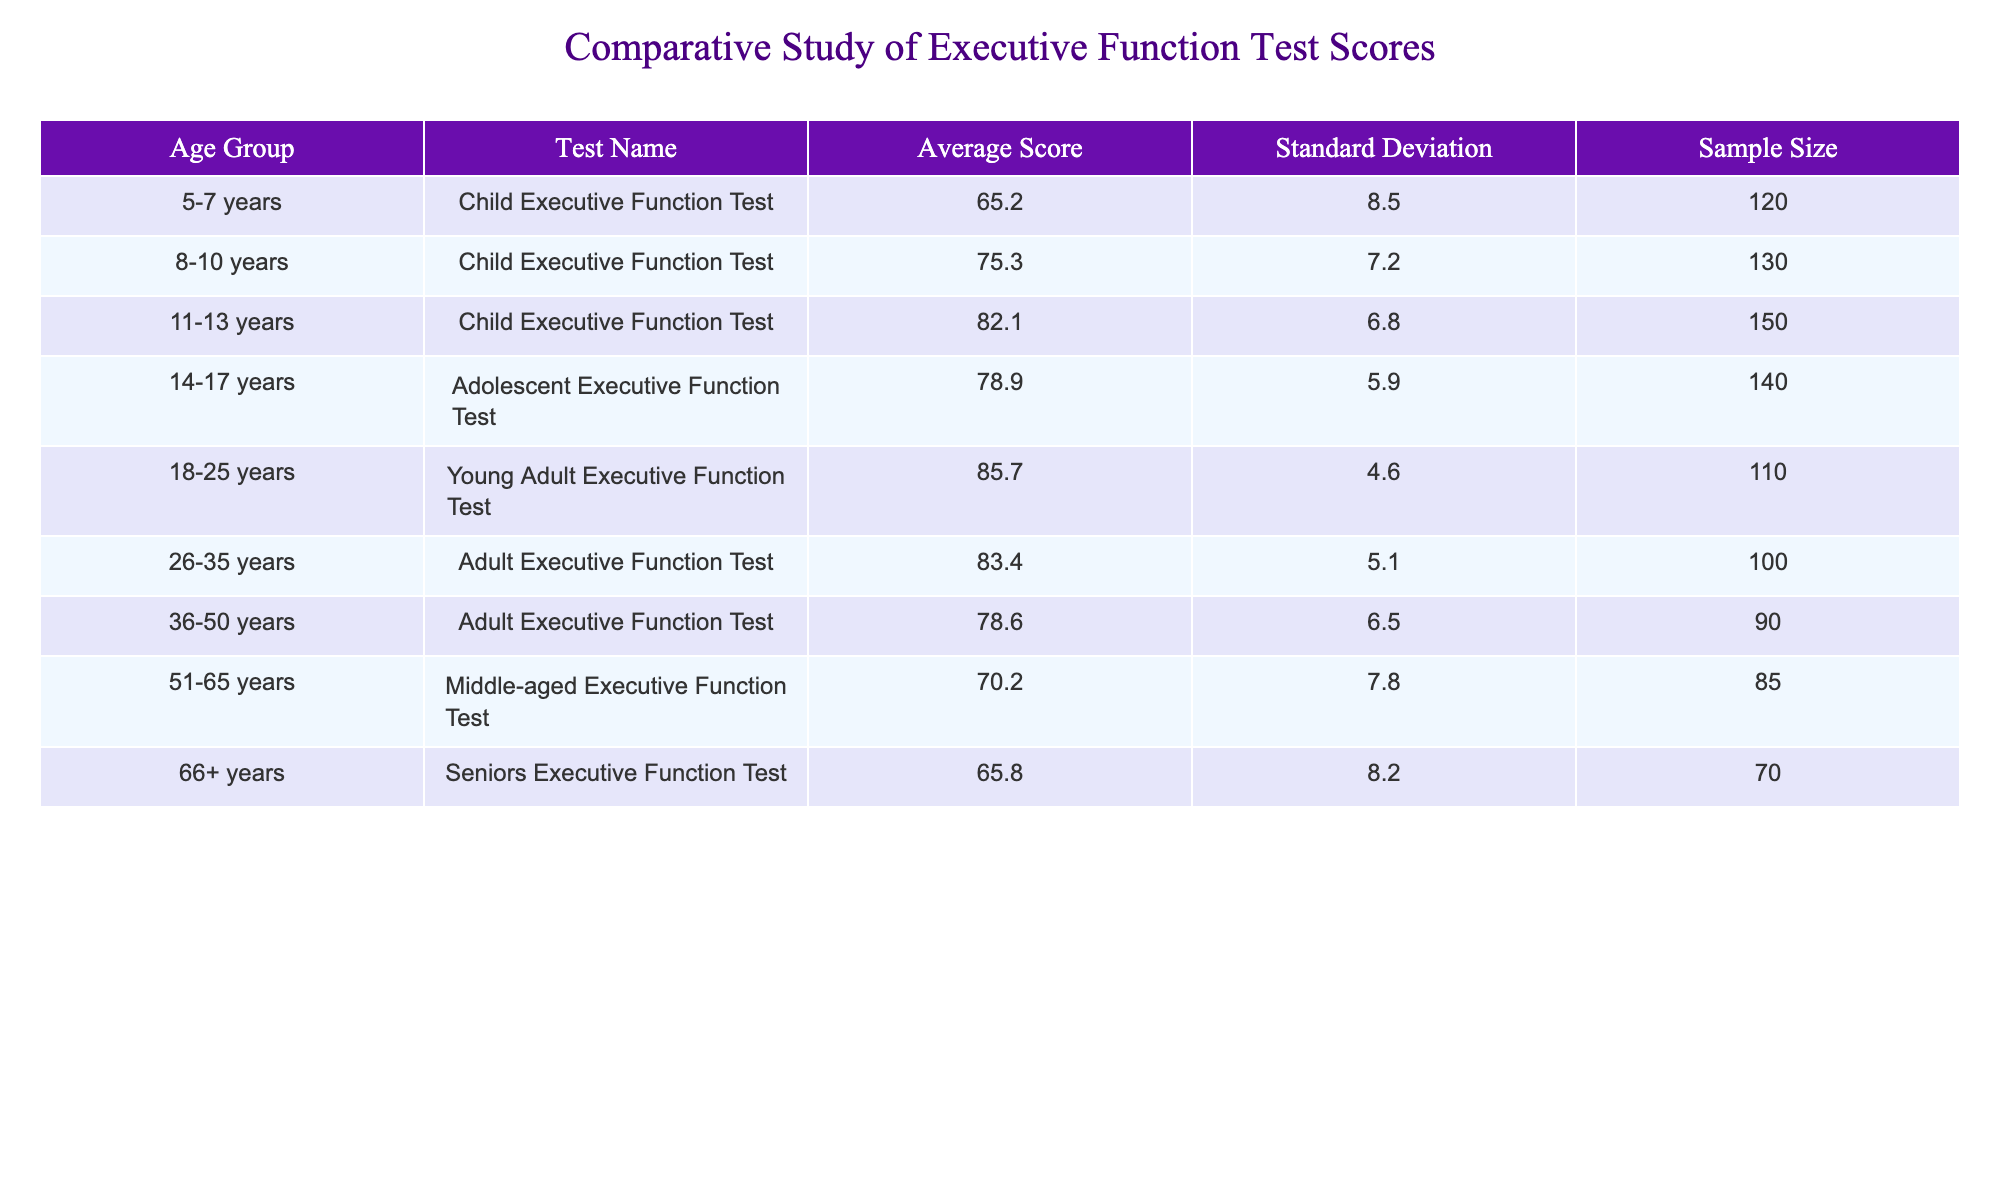What is the average score for the 8-10 years age group? The table shows the average score for the 8-10 years age group as 75.3. There is no further calculation needed since the value is directly provided.
Answer: 75.3 What is the sample size for the 14-17 years age group? The table lists the sample size for the 14-17 years age group as 140. This is obtained directly from the relevant column in the table.
Answer: 140 Which age group has the highest average score? The young adult age group (18-25 years) has the highest average score of 85.7, which can be confirmed by comparing all average scores from the table.
Answer: 18-25 years What is the difference in average score between the 11-13 years and the 36-50 years age groups? The average score for the 11-13 years age group is 82.1, and for the 36-50 years age group, it is 78.6. The difference is calculated as 82.1 - 78.6 = 3.5.
Answer: 3.5 Is the statement "Adults have a higher average score than seniors" true? To verify this statement, we check the average scores: Adults (26-35 years) average 83.4, while Seniors (66+ years) average 65.8. Since 83.4 is greater than 65.8, the statement is true.
Answer: Yes What is the average score of all age groups combined? First, the average scores for all age groups should be summed: 65.2 + 75.3 + 82.1 + 78.9 + 85.7 + 83.4 + 78.6 + 70.2 + 65.8 =  775.2. Then, we divide by the number of age groups (9), resulting in 775.2 / 9 = 86.13 (rounded to two decimal places).
Answer: 86.13 Which age group scores below the overall average, if the overall average is found to be 78.4? To identify which age groups score below 78.4, we compare each average score against this benchmark. The age groups with scores below 78.4 are 5-7 years (65.2), 36-50 years (78.6), and seniors (65.8).
Answer: 5-7 years, 36-50 years, and Seniors What is the standard deviation for the average score of the 26-35 years age group? The standard deviation for the 26-35 years age group is provided directly in the table as 5.1, requiring no calculations or further reasoning.
Answer: 5.1 How does the standard deviation for adolescents compare to that of the young adults? The standard deviation for adolescents (14-17 years) is 5.9 and for young adults (18-25 years) is 4.6. We compare these two values, noting that 5.9 is greater than 4.6. Thus, adolescents exhibit more variability in their scores compared to young adults.
Answer: Adolescents have a higher standard deviation 